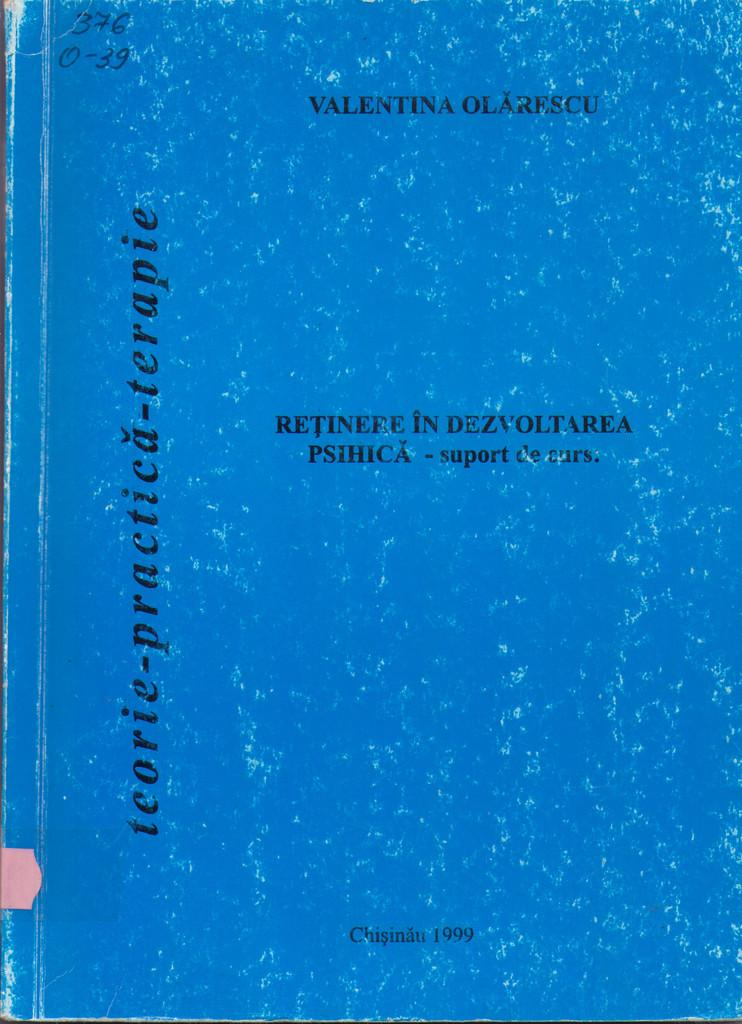<image>
Create a compact narrative representing the image presented. A blue covered book which has Valentina Olarescu as the author. 